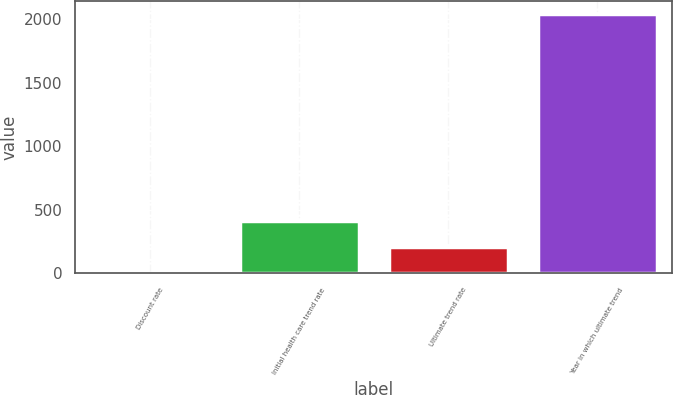<chart> <loc_0><loc_0><loc_500><loc_500><bar_chart><fcel>Discount rate<fcel>Initial health care trend rate<fcel>Ultimate trend rate<fcel>Year in which ultimate trend<nl><fcel>3.5<fcel>410.4<fcel>206.95<fcel>2038<nl></chart> 